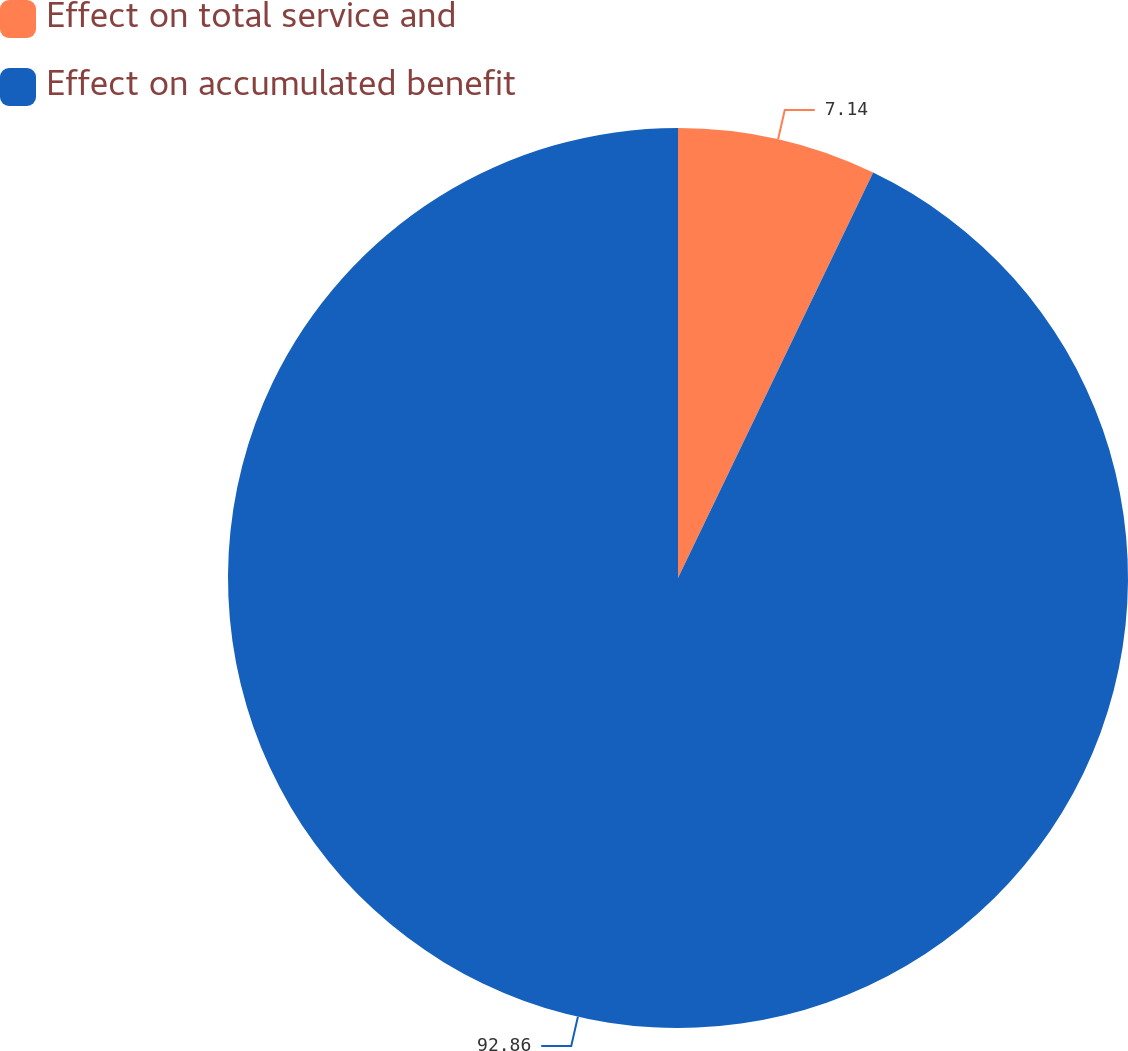<chart> <loc_0><loc_0><loc_500><loc_500><pie_chart><fcel>Effect on total service and<fcel>Effect on accumulated benefit<nl><fcel>7.14%<fcel>92.86%<nl></chart> 